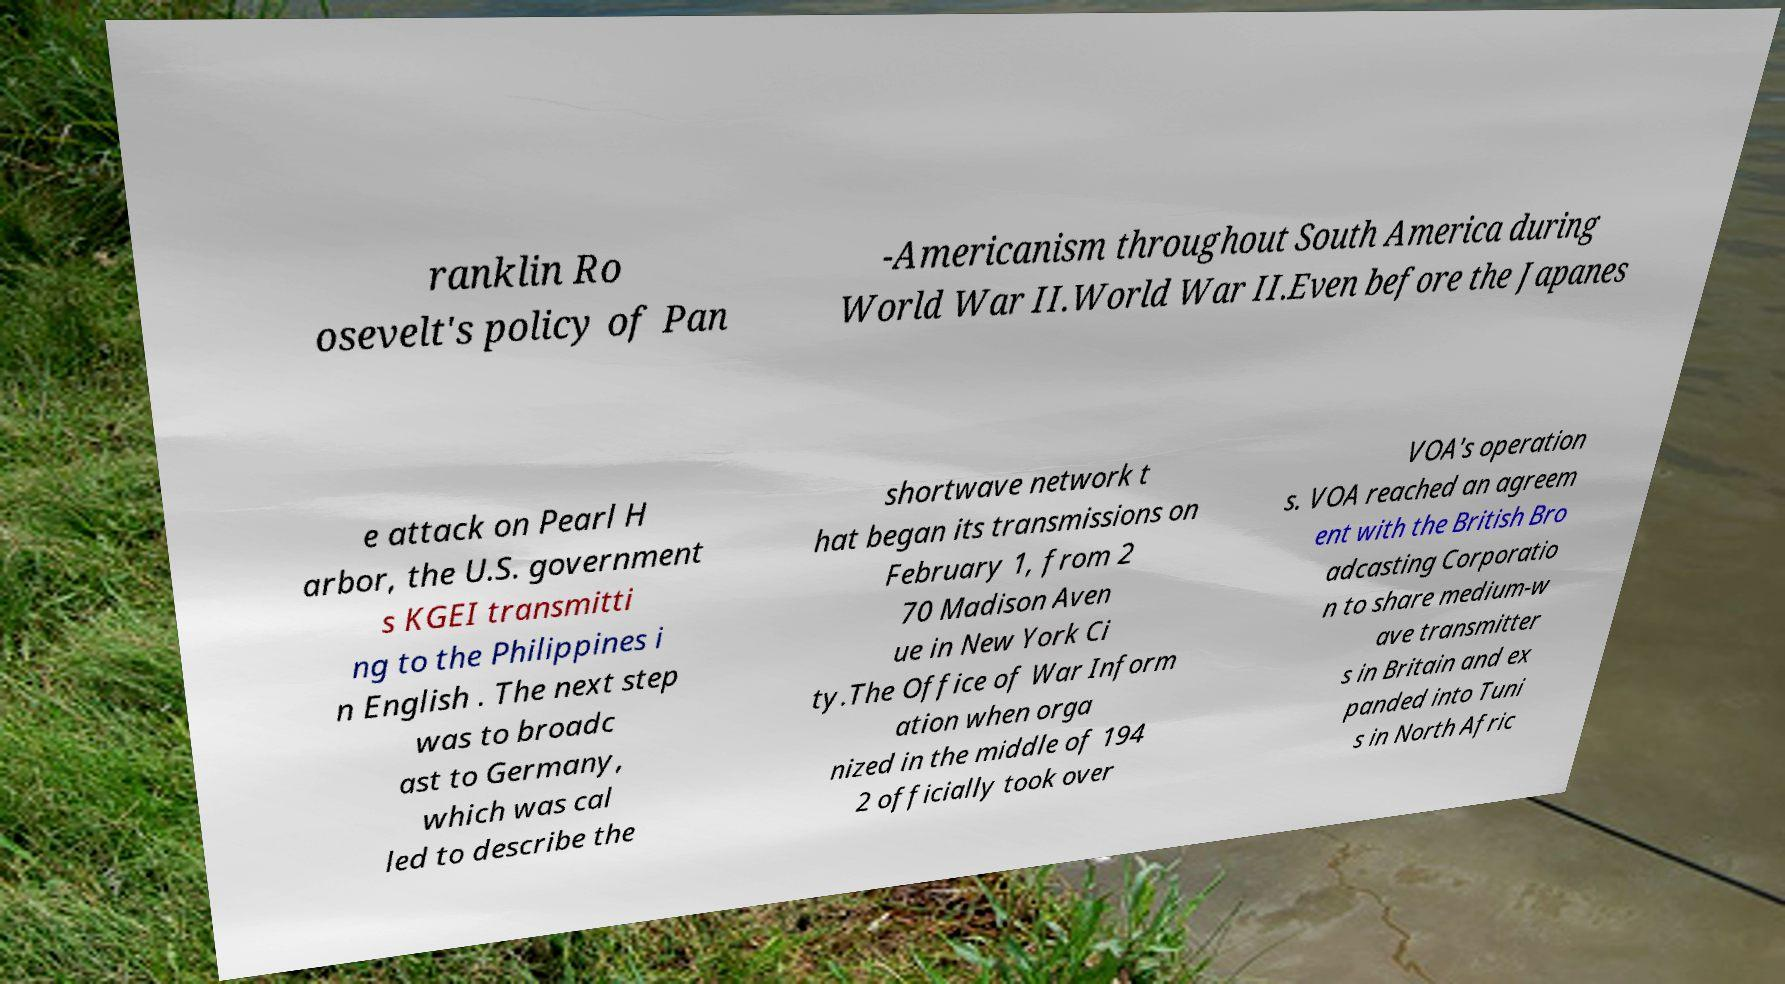There's text embedded in this image that I need extracted. Can you transcribe it verbatim? ranklin Ro osevelt's policy of Pan -Americanism throughout South America during World War II.World War II.Even before the Japanes e attack on Pearl H arbor, the U.S. government s KGEI transmitti ng to the Philippines i n English . The next step was to broadc ast to Germany, which was cal led to describe the shortwave network t hat began its transmissions on February 1, from 2 70 Madison Aven ue in New York Ci ty.The Office of War Inform ation when orga nized in the middle of 194 2 officially took over VOA's operation s. VOA reached an agreem ent with the British Bro adcasting Corporatio n to share medium-w ave transmitter s in Britain and ex panded into Tuni s in North Afric 